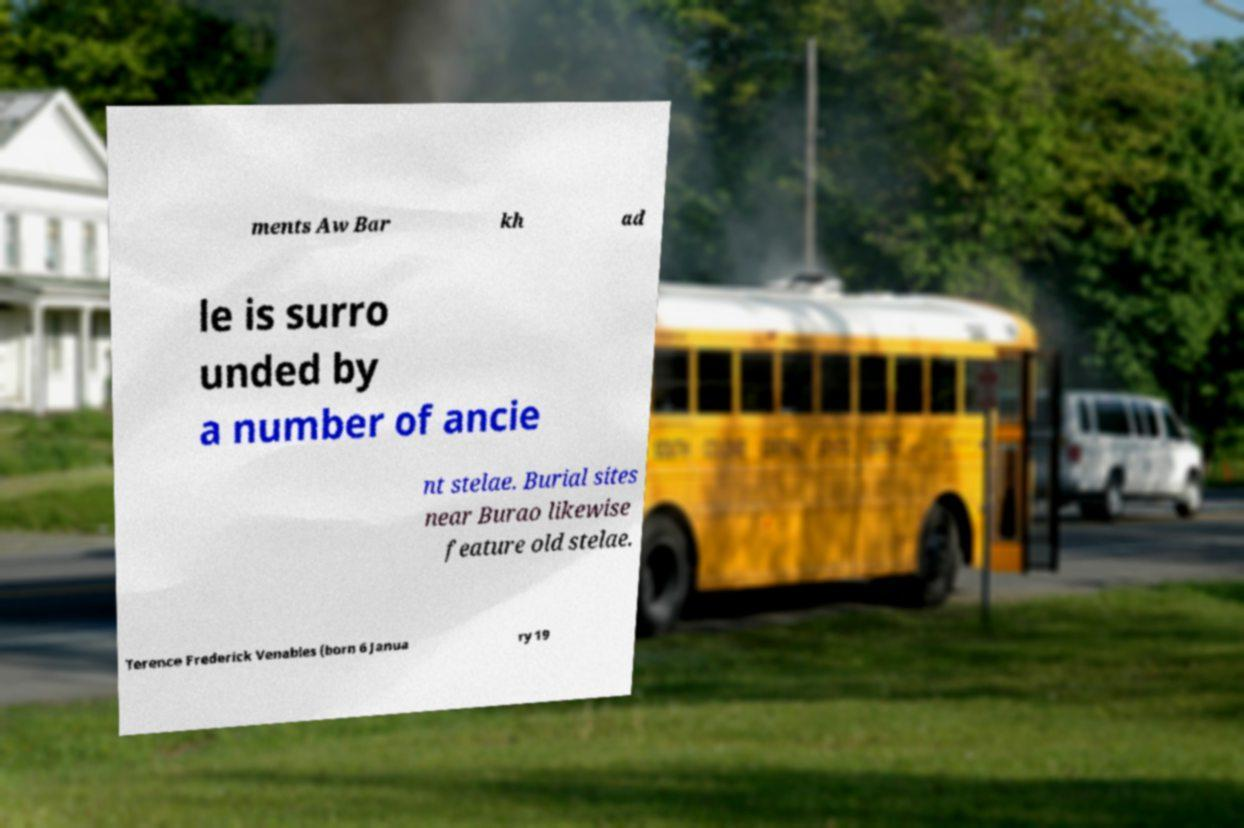I need the written content from this picture converted into text. Can you do that? ments Aw Bar kh ad le is surro unded by a number of ancie nt stelae. Burial sites near Burao likewise feature old stelae. Terence Frederick Venables (born 6 Janua ry 19 